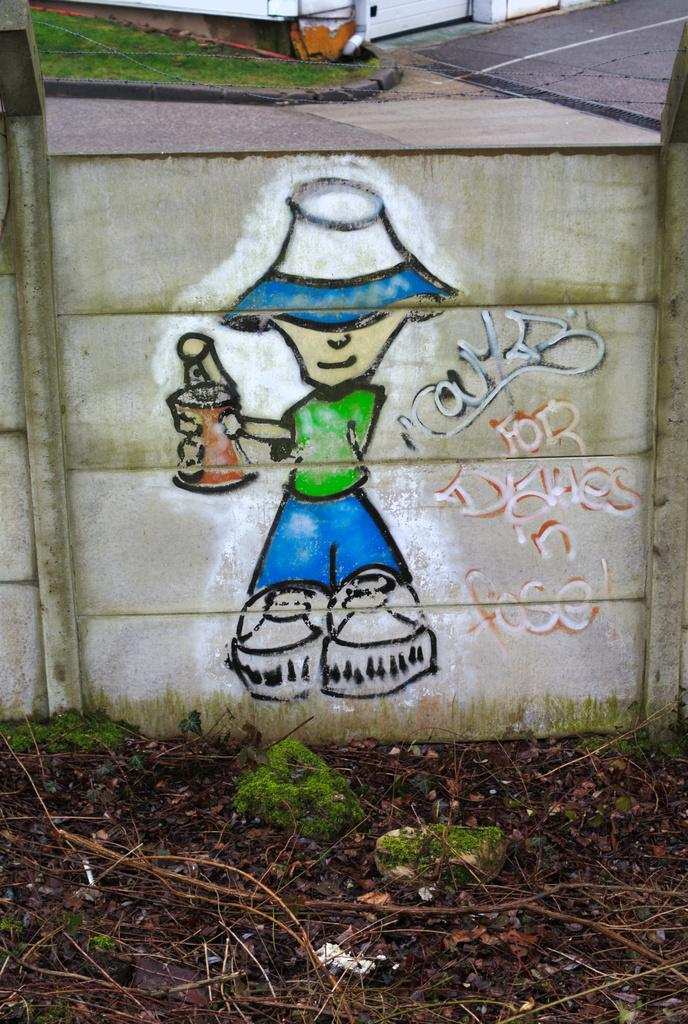What is the main subject in the center of the image? There is a wall in the center of the image. What is depicted on the wall? There is a graffiti picture on the wall. Are there any words or phrases on the wall? Yes, there is some text on the wall. What can be seen in the top part of the image? There is a road visible at the top of the image, and there is also a building. Can you tell me how many birds are flying in the sky in the image? There is no sky visible in the image, and therefore no birds can be seen flying. 